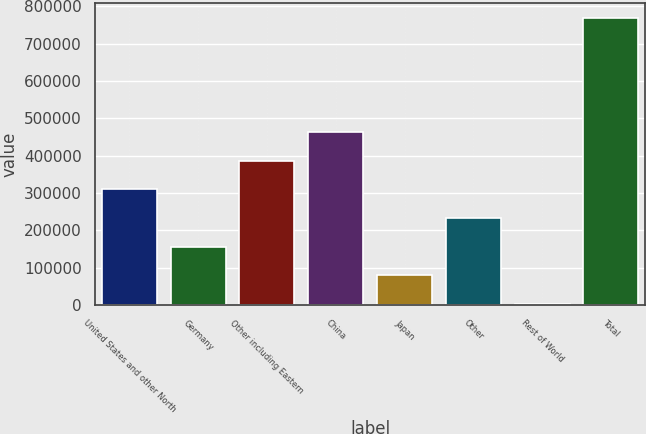Convert chart to OTSL. <chart><loc_0><loc_0><loc_500><loc_500><bar_chart><fcel>United States and other North<fcel>Germany<fcel>Other including Eastern<fcel>China<fcel>Japan<fcel>Other<fcel>Rest of World<fcel>Total<nl><fcel>309778<fcel>156427<fcel>386454<fcel>463130<fcel>79751.6<fcel>233103<fcel>3076<fcel>769832<nl></chart> 